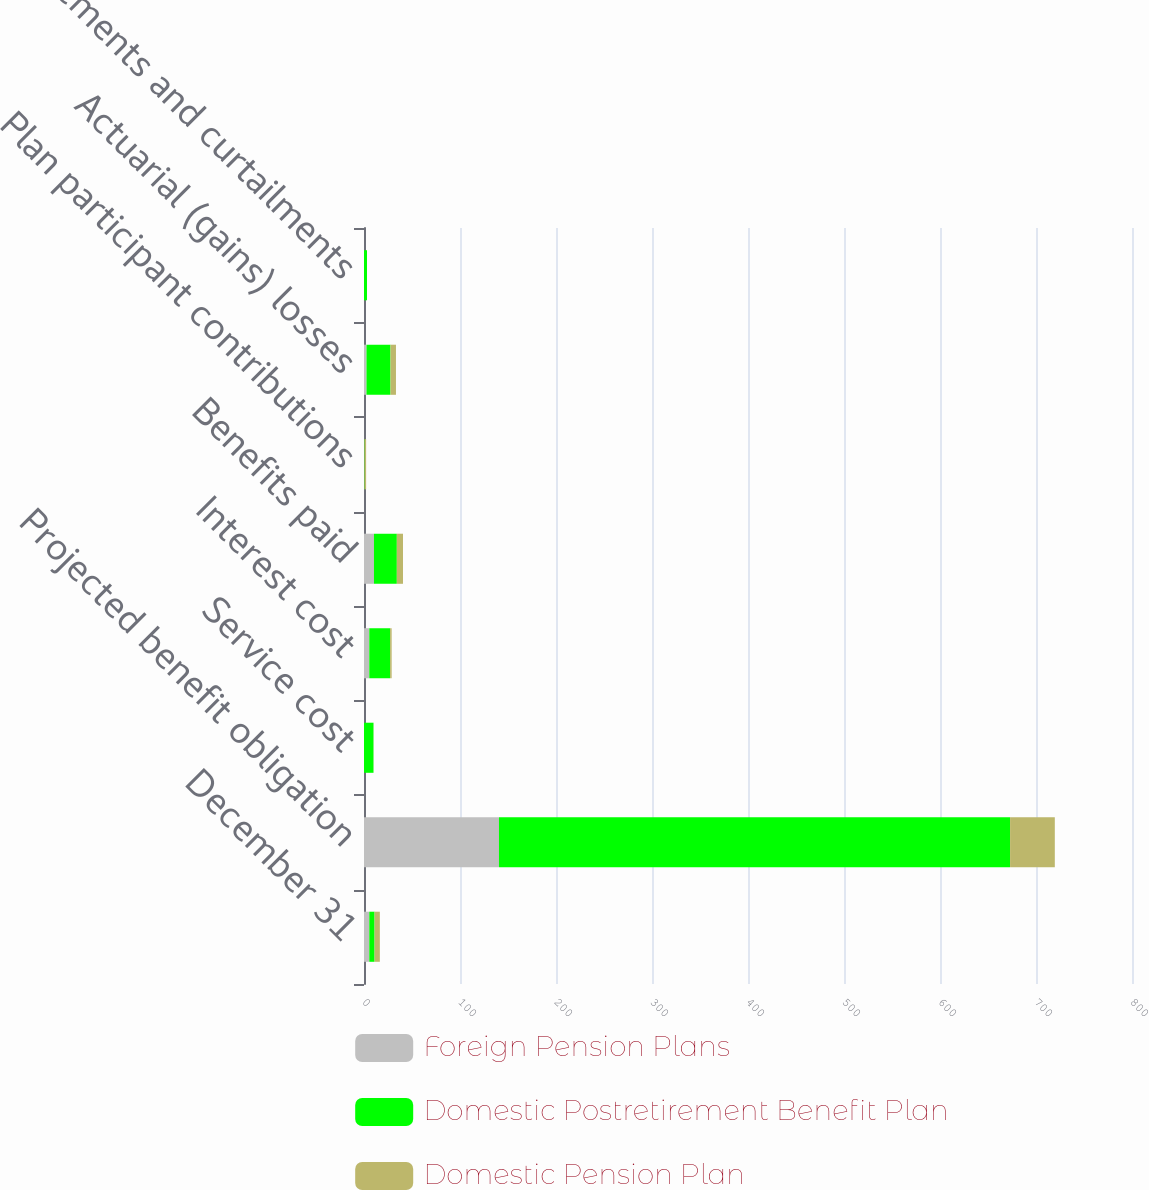Convert chart to OTSL. <chart><loc_0><loc_0><loc_500><loc_500><stacked_bar_chart><ecel><fcel>December 31<fcel>Projected benefit obligation<fcel>Service cost<fcel>Interest cost<fcel>Benefits paid<fcel>Plan participant contributions<fcel>Actuarial (gains) losses<fcel>Settlements and curtailments<nl><fcel>Foreign Pension Plans<fcel>5.5<fcel>140.6<fcel>0<fcel>5.5<fcel>10.4<fcel>0<fcel>2.6<fcel>0<nl><fcel>Domestic Postretirement Benefit Plan<fcel>5.5<fcel>532.4<fcel>9.9<fcel>21.7<fcel>23.8<fcel>0.5<fcel>25<fcel>3.1<nl><fcel>Domestic Pension Plan<fcel>5.5<fcel>46.6<fcel>0.1<fcel>1.6<fcel>6.4<fcel>1.7<fcel>5.7<fcel>0<nl></chart> 